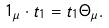<formula> <loc_0><loc_0><loc_500><loc_500>1 _ { \mu } \cdot t _ { 1 } = t _ { 1 } \Theta _ { \mu } .</formula> 